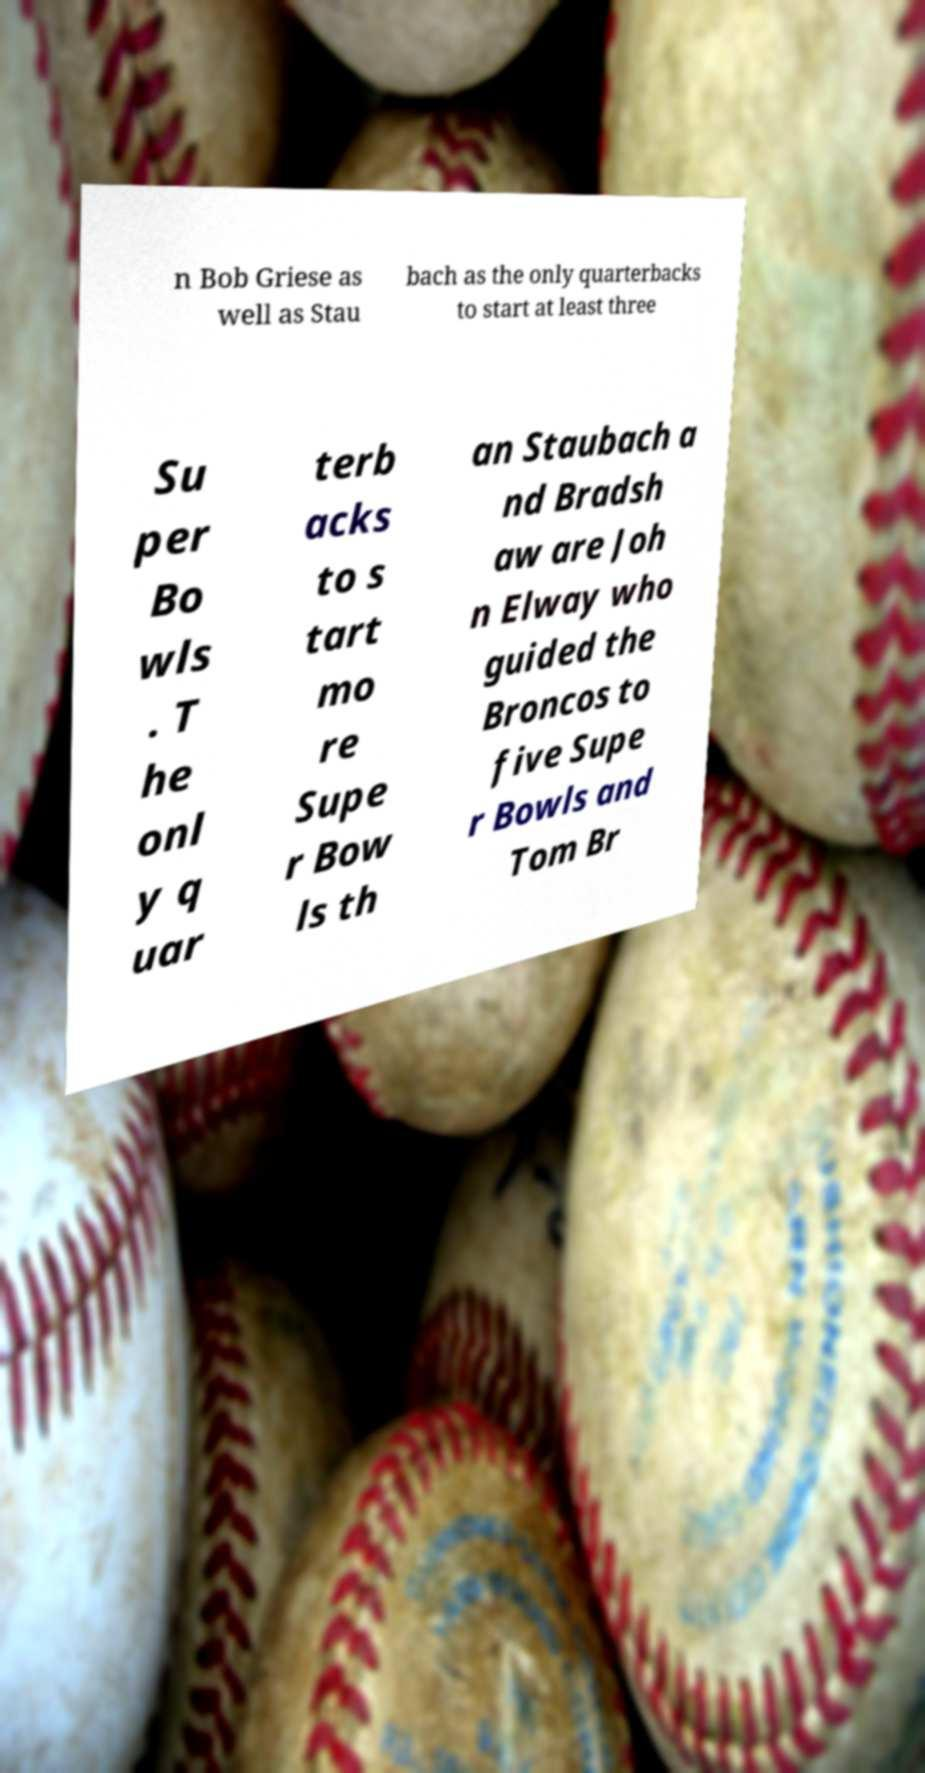Could you extract and type out the text from this image? n Bob Griese as well as Stau bach as the only quarterbacks to start at least three Su per Bo wls . T he onl y q uar terb acks to s tart mo re Supe r Bow ls th an Staubach a nd Bradsh aw are Joh n Elway who guided the Broncos to five Supe r Bowls and Tom Br 